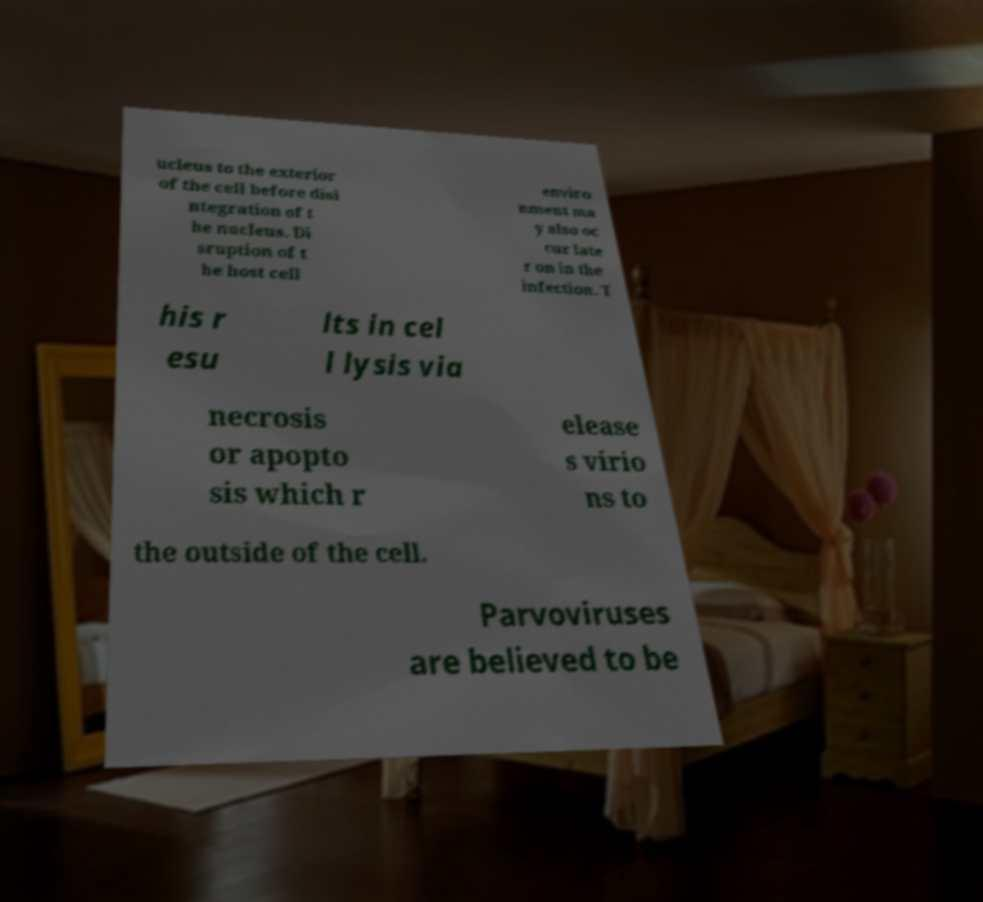For documentation purposes, I need the text within this image transcribed. Could you provide that? ucleus to the exterior of the cell before disi ntegration of t he nucleus. Di sruption of t he host cell enviro nment ma y also oc cur late r on in the infection. T his r esu lts in cel l lysis via necrosis or apopto sis which r elease s virio ns to the outside of the cell. Parvoviruses are believed to be 